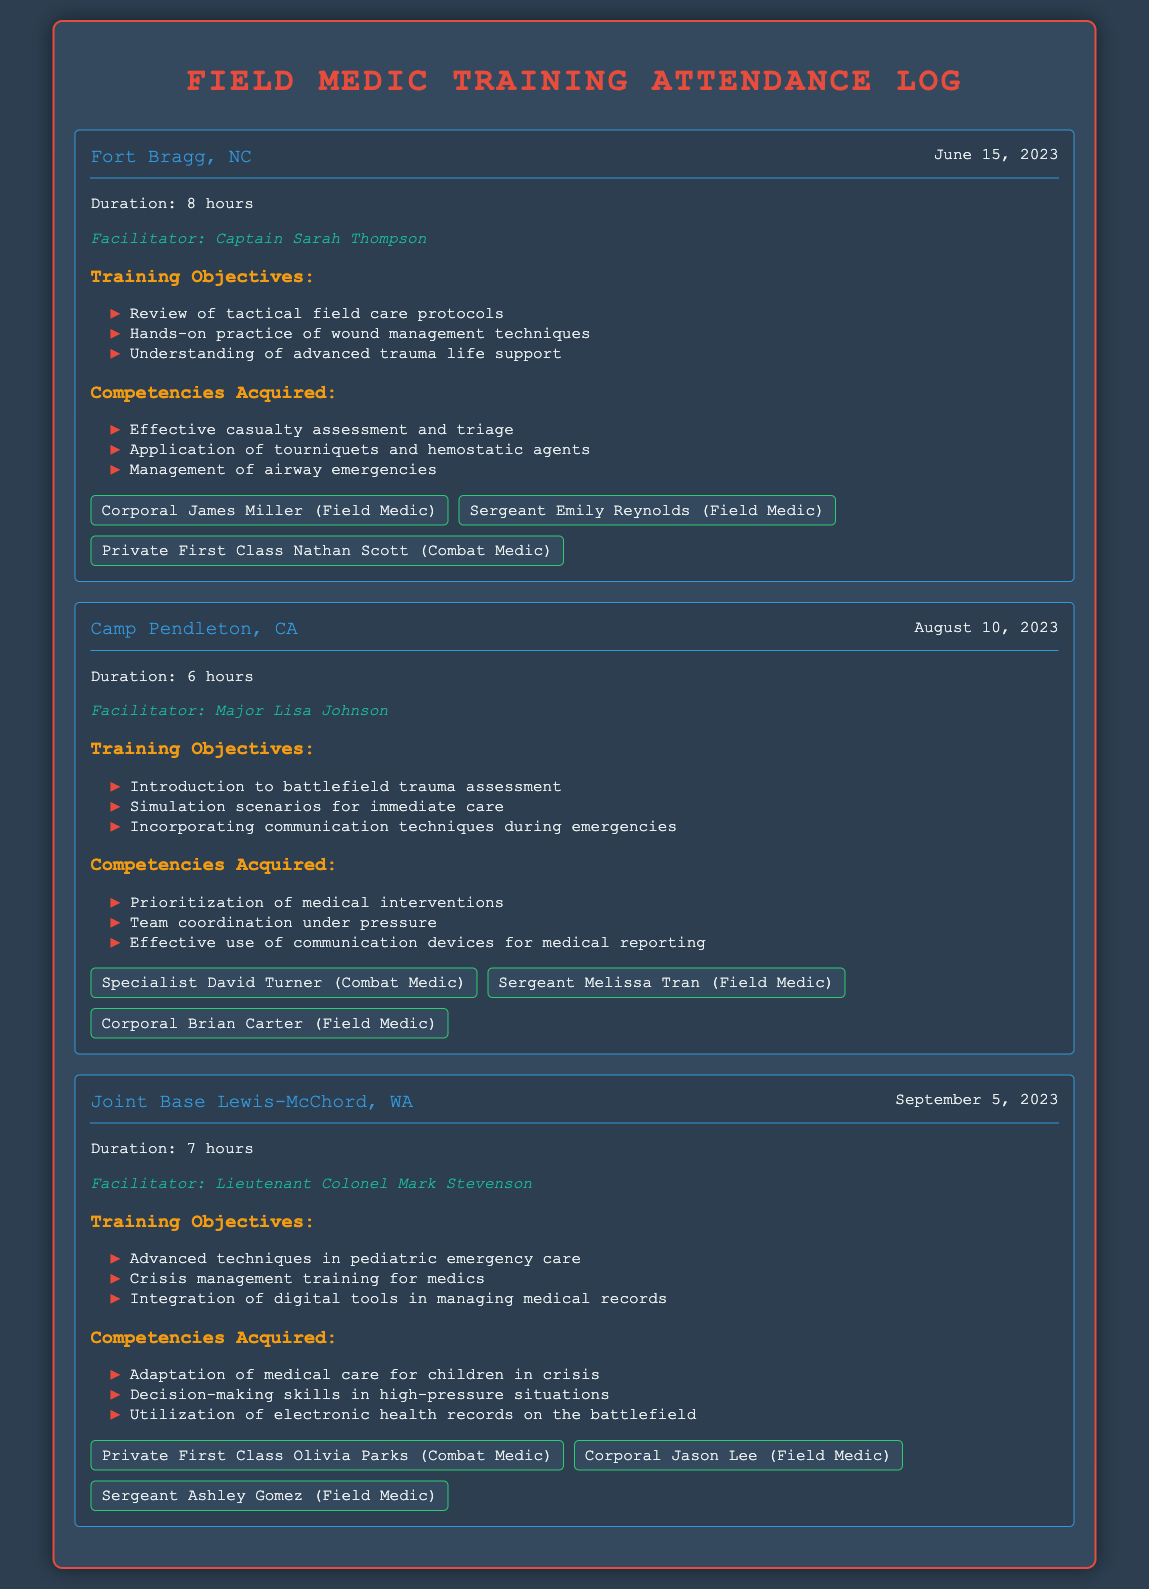What is the date of the training session at Fort Bragg? The date for the training session at Fort Bragg is specifically mentioned in the document, which is June 15, 2023.
Answer: June 15, 2023 Who facilitated the training session at Camp Pendleton? The facilitator of the Camp Pendleton session is explicitly noted as Major Lisa Johnson.
Answer: Major Lisa Johnson How many hours was the training session held at Joint Base Lewis-McChord? The document states that the duration of the training session at Joint Base Lewis-McChord was 7 hours.
Answer: 7 hours What is one competency acquired during the Fort Bragg training session? One of the competencies acquired during the training at Fort Bragg is listed as effective casualty assessment and triage.
Answer: Effective casualty assessment and triage Which participants attended the training at Fort Bragg? The document lists the specific participants who attended the Fort Bragg session, including Corporal James Miller, Sergeant Emily Reynolds, and Private First Class Nathan Scott.
Answer: Corporal James Miller, Sergeant Emily Reynolds, Private First Class Nathan Scott What is one objective of the training session at Camp Pendleton? One of the training objectives at Camp Pendleton is the introduction to battlefield trauma assessment, as detailed in the document.
Answer: Introduction to battlefield trauma assessment How many participants were present at the Joint Base Lewis-McChord training session? The document mentions the names of three participants present at the Joint Base Lewis-McChord training session.
Answer: Three What type of training is emphasized in the last session? The document highlights advanced techniques in pediatric emergency care as one of the main focuses of the last training session.
Answer: Advanced techniques in pediatric emergency care 